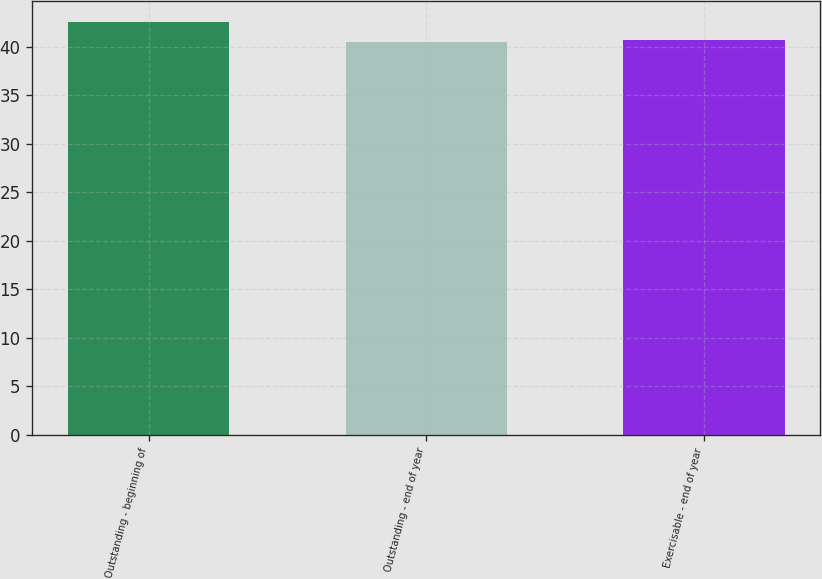Convert chart. <chart><loc_0><loc_0><loc_500><loc_500><bar_chart><fcel>Outstanding - beginning of<fcel>Outstanding - end of year<fcel>Exercisable - end of year<nl><fcel>42.58<fcel>40.48<fcel>40.69<nl></chart> 